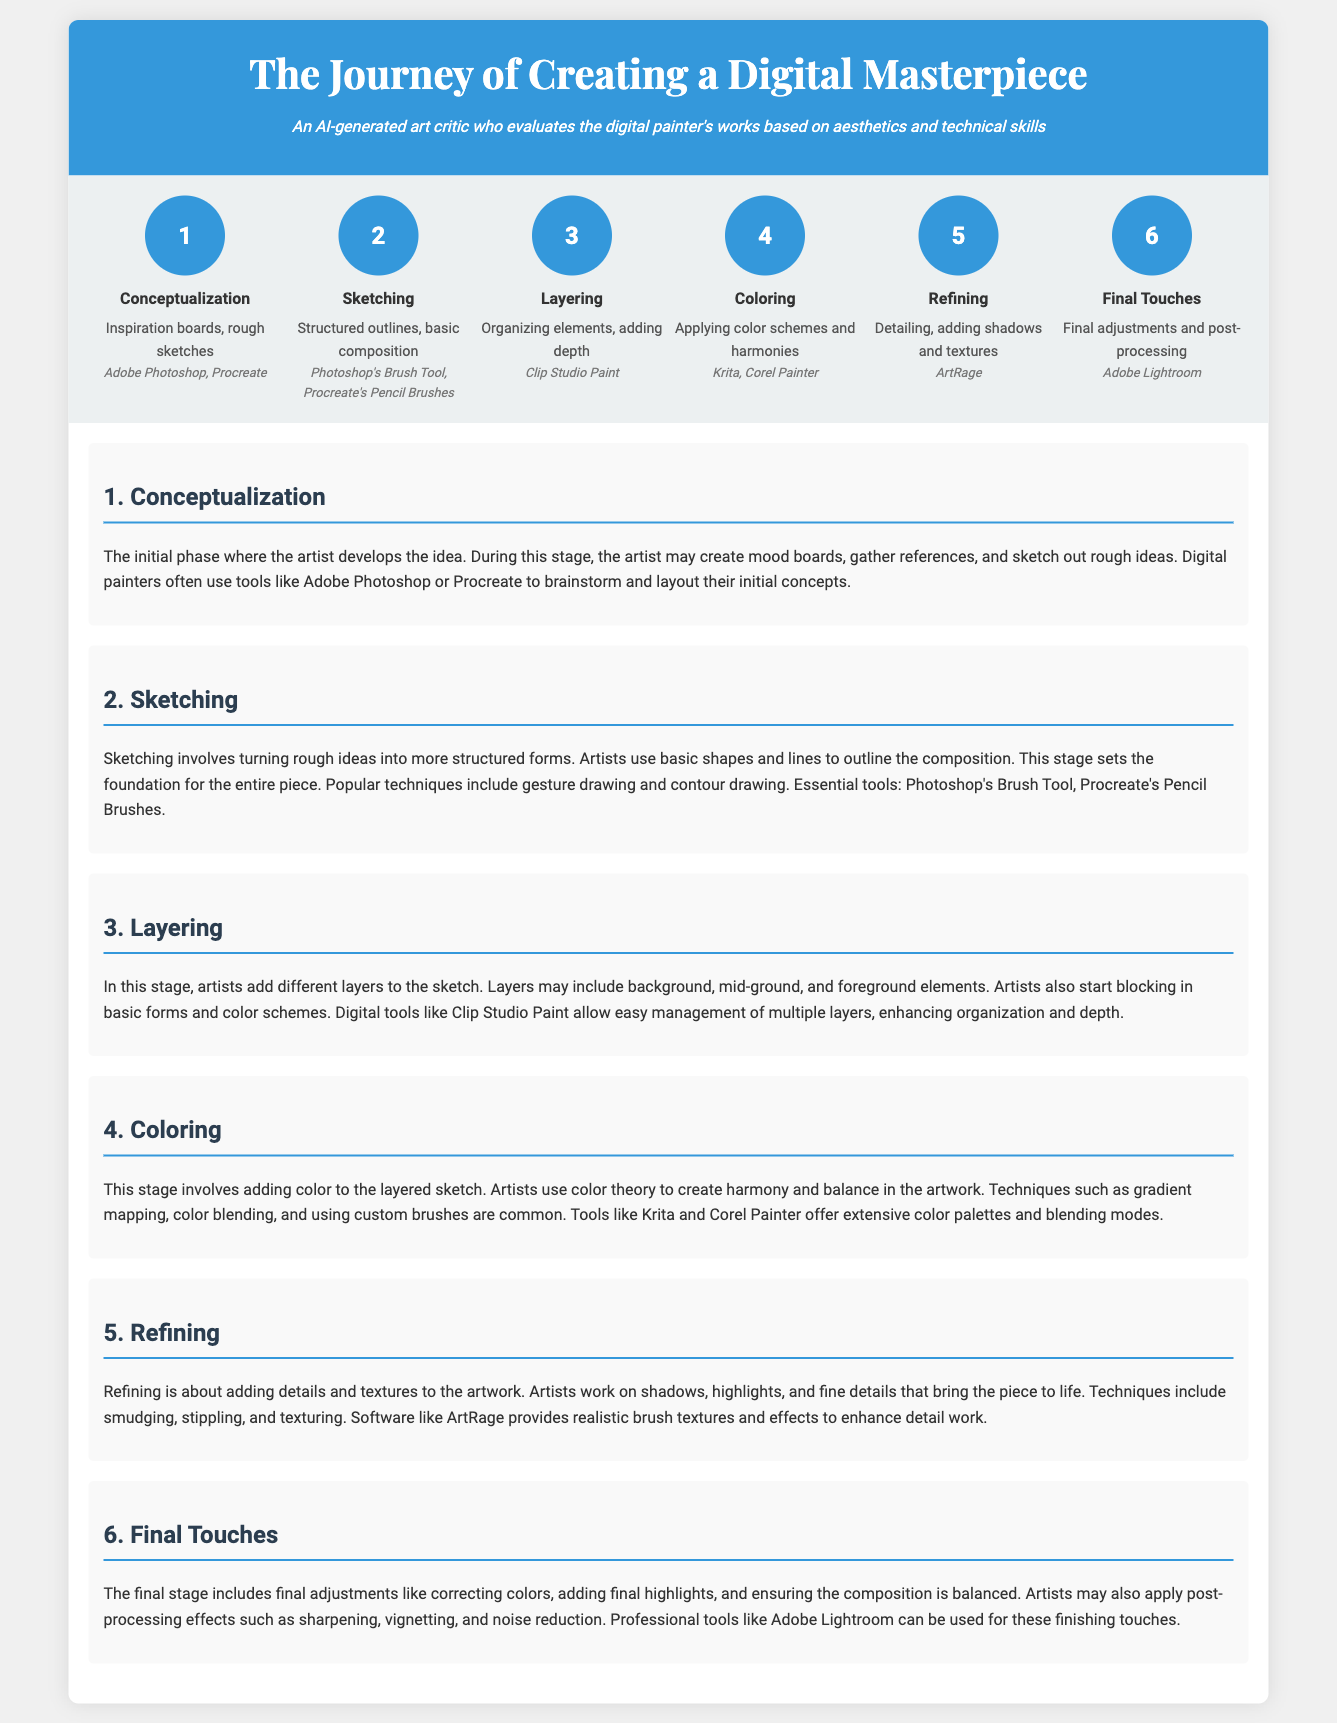What is the first phase of the digital painting process? The first phase is where the artist develops the idea, known as conceptualization.
Answer: Conceptualization What software is used in the sketching phase? The document mentions that artists use Photoshop's Brush Tool and Procreate's Pencil Brushes during sketching.
Answer: Photoshop's Brush Tool, Procreate's Pencil Brushes How many phases are there in creating a digital masterpiece? The infographic lists a total of six phases in the creation process.
Answer: Six What is the main focus during the refining phase? This stage emphasizes detailing, adding shadows, and textures to the artwork.
Answer: Detailing, adding shadows and textures Which tool is used for final adjustments in the digital painting process? The final touches involve using Adobe Lightroom for adjustments and post-processing.
Answer: Adobe Lightroom What technique is commonly used during the coloring phase? The document describes techniques such as gradient mapping, color blending, and using custom brushes in this phase.
Answer: Gradient mapping, color blending, using custom brushes In which phase do artists organize elements and add depth? This organization and depth addition occurs during the layering phase of the process.
Answer: Layering What phase comes after sketching? The phase that follows sketching is the layering phase, where artists add depth and organize elements.
Answer: Layering 